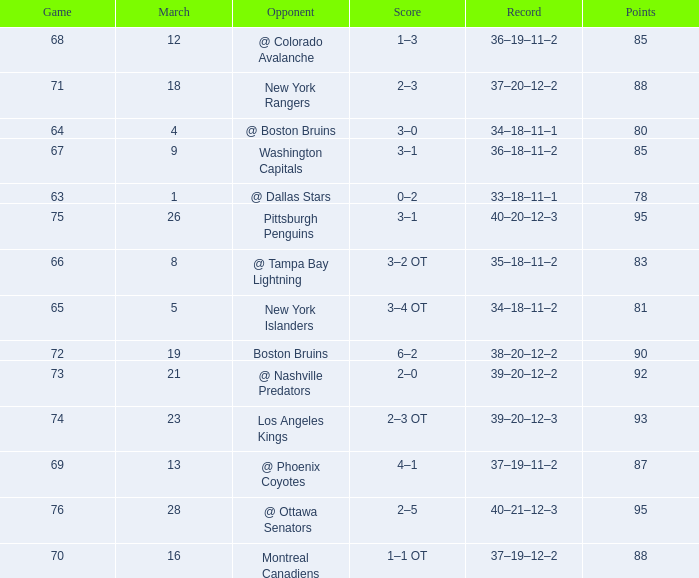Which Game is the highest one that has Points smaller than 92, and a Score of 1–3? 68.0. 